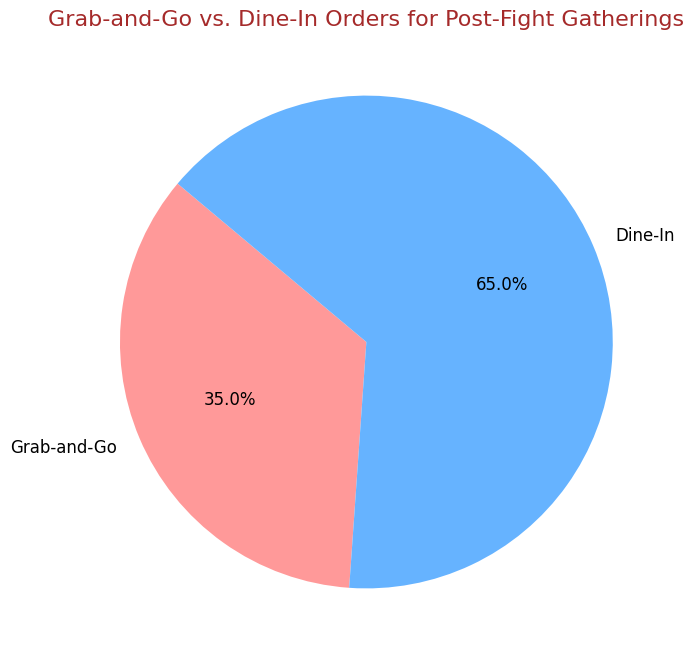How many of the total orders are categorized as Dine-In? The pie chart shows that 65% of the orders are categorized as Dine-In. If we assume 100 total orders, then the number of Dine-In orders is 65% of 100, which is 0.65 * 100 = 65.
Answer: 65 What fraction of the total orders are Grab-and-Go? The pie chart indicates that Grab-and-Go orders make up 35% of the total. The fraction of Grab-and-Go orders is therefore 35/100, which simplifies to 7/20.
Answer: 7/20 Which type of order is more common? By looking at the percentage values on the pie chart, it is clear that Dine-In orders (65%) are more common than Grab-and-Go orders (35%).
Answer: Dine-In What is the percentage difference between Dine-In and Grab-and-Go orders? The Dine-In orders are 65% and the Grab-and-Go orders are 35%. The percentage difference between them is 65% - 35% = 30%.
Answer: 30% What percentage of orders are not Grab-and-Go? The percentage of Grab-and-Go orders is 35%. Therefore, the percentage of orders that are not Grab-and-Go is 100% - 35% = 65%.
Answer: 65% If the total number of orders is 200, how many orders are Dine-In? According to the pie chart, Dine-In orders account for 65% of total orders. With 200 total orders, the number of Dine-In orders is 0.65 * 200 = 130.
Answer: 130 Which segment of the pie chart is larger, and how can you tell? The Dine-In segment is larger, which can be deduced from its percentage (65%) being greater than the percentage of the Grab-and-Go segment (35%). Visually, the Dine-In segment occupies a larger portion of the pie chart.
Answer: Dine-In, larger If the total orders were split equally between Grab-and-Go and Dine-In next time, what would the percentage be for each type? If orders were equally split, each type would represent half of the total. So, the percentage for each type would be 100% / 2 = 50%.
Answer: 50% for each type What is the title of the pie chart? The title of the pie chart, as shown at the top, is "Grab-and-Go vs. Dine-In Orders for Post-Fight Gatherings".
Answer: Grab-and-Go vs. Dine-In Orders for Post-Fight Gatherings 